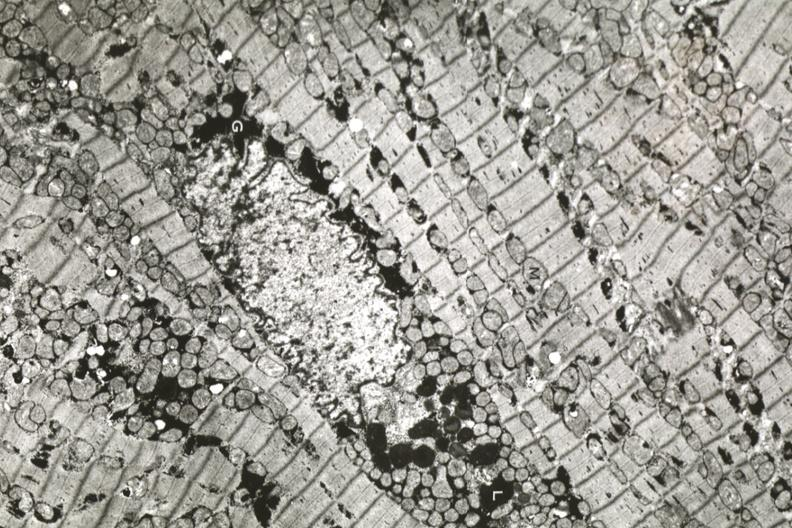s atrophy present?
Answer the question using a single word or phrase. Yes 